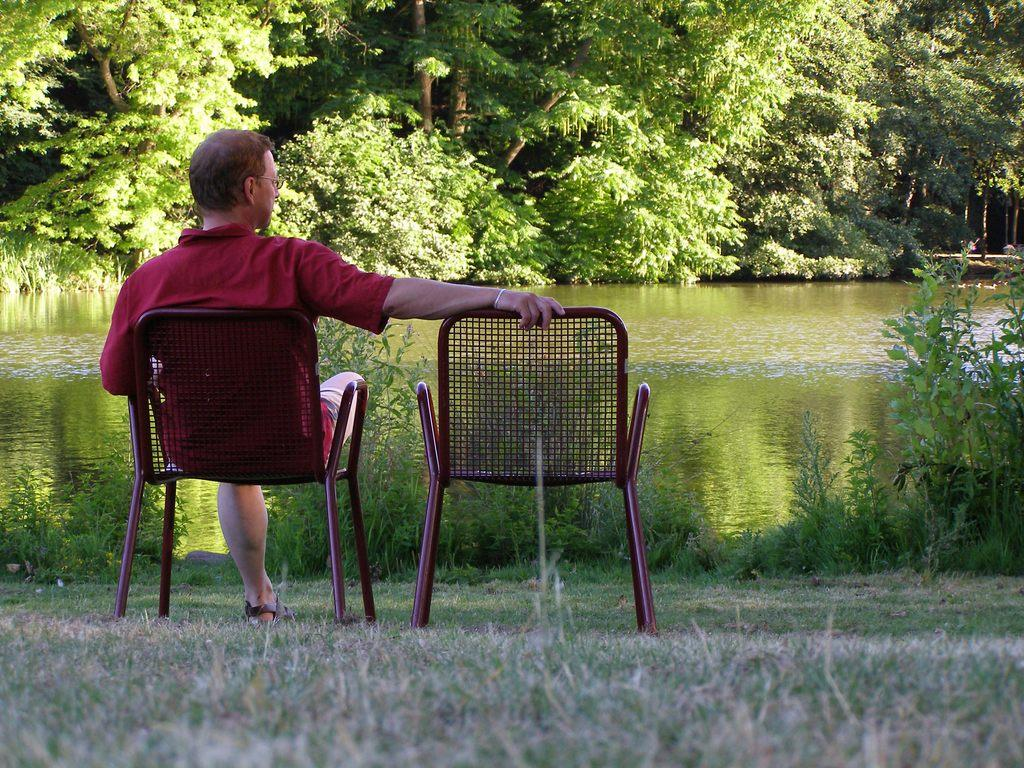What is the person in the image doing? The person is sitting on a chair on the left side of the image. What type of vegetation can be seen in the image? There is green grass visible in the image. What natural element is present in the image? There is water visible in the image. What can be seen in the distance in the image? There are trees in the background of the image. What type of oil is being used to maintain the grass in the image? There is no mention of oil being used to maintain the grass in the image. The grass appears to be naturally green. 